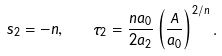<formula> <loc_0><loc_0><loc_500><loc_500>s _ { 2 } = - n , \quad \tau _ { 2 } = \frac { n a _ { 0 } } { 2 a _ { 2 } } \left ( \frac { A } { a _ { 0 } } \right ) ^ { 2 / n } .</formula> 